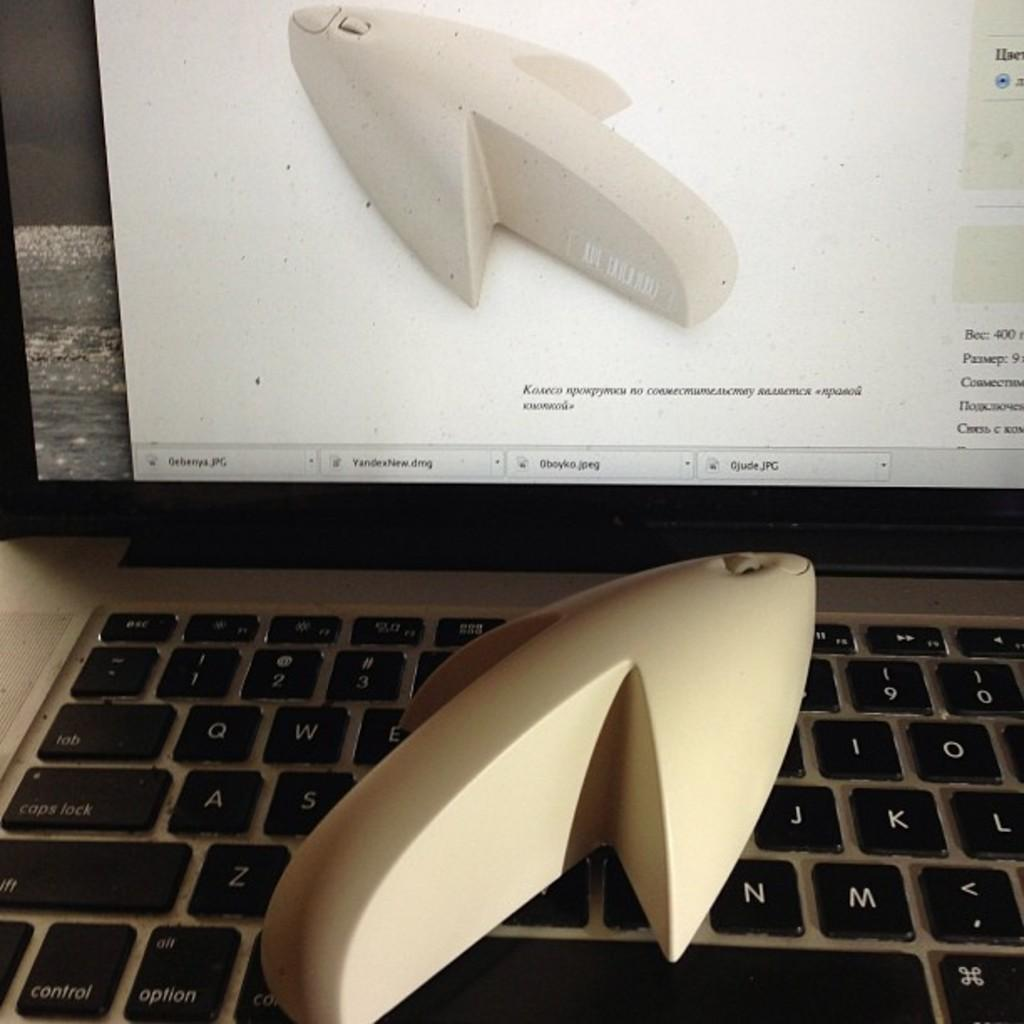Provide a one-sentence caption for the provided image. Three .jpg files and a .dmg file are open, one of which shows the same object that is on the keyboard. 